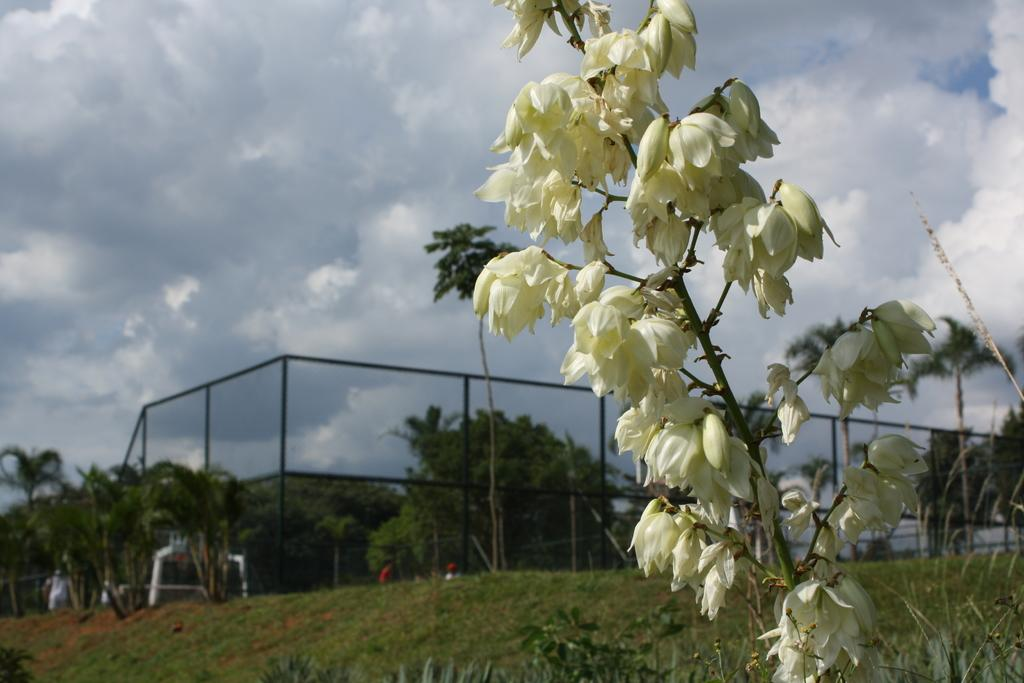What type of vegetation can be seen in the image? There are plants, grass, and trees in the image. What type of barrier is present in the image? There is a fence in the image. Who or what is present in the image besides the vegetation and fence? There is a group of people in the image. What is visible in the background of the image? The sky is visible in the background of the image. Can you describe the setting where the image might have been taken? The image may have been taken in a park, given the presence of plants, grass, trees, and a fence. What type of jam is being spread on the crate in the image? There is no crate or jam present in the image. How does the behavior of the plants in the image change throughout the day? The image does not show any changes in the behavior of the plants, as it is a still image. 